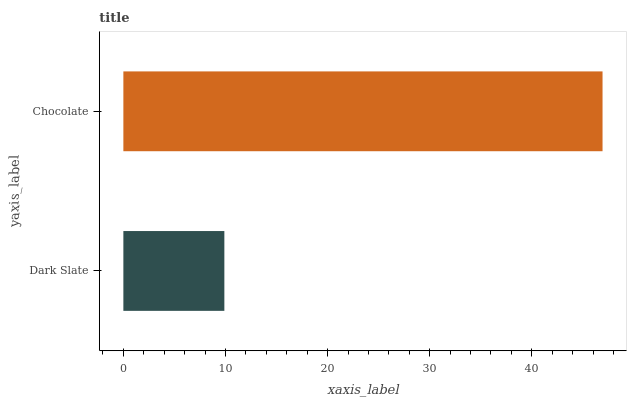Is Dark Slate the minimum?
Answer yes or no. Yes. Is Chocolate the maximum?
Answer yes or no. Yes. Is Chocolate the minimum?
Answer yes or no. No. Is Chocolate greater than Dark Slate?
Answer yes or no. Yes. Is Dark Slate less than Chocolate?
Answer yes or no. Yes. Is Dark Slate greater than Chocolate?
Answer yes or no. No. Is Chocolate less than Dark Slate?
Answer yes or no. No. Is Chocolate the high median?
Answer yes or no. Yes. Is Dark Slate the low median?
Answer yes or no. Yes. Is Dark Slate the high median?
Answer yes or no. No. Is Chocolate the low median?
Answer yes or no. No. 